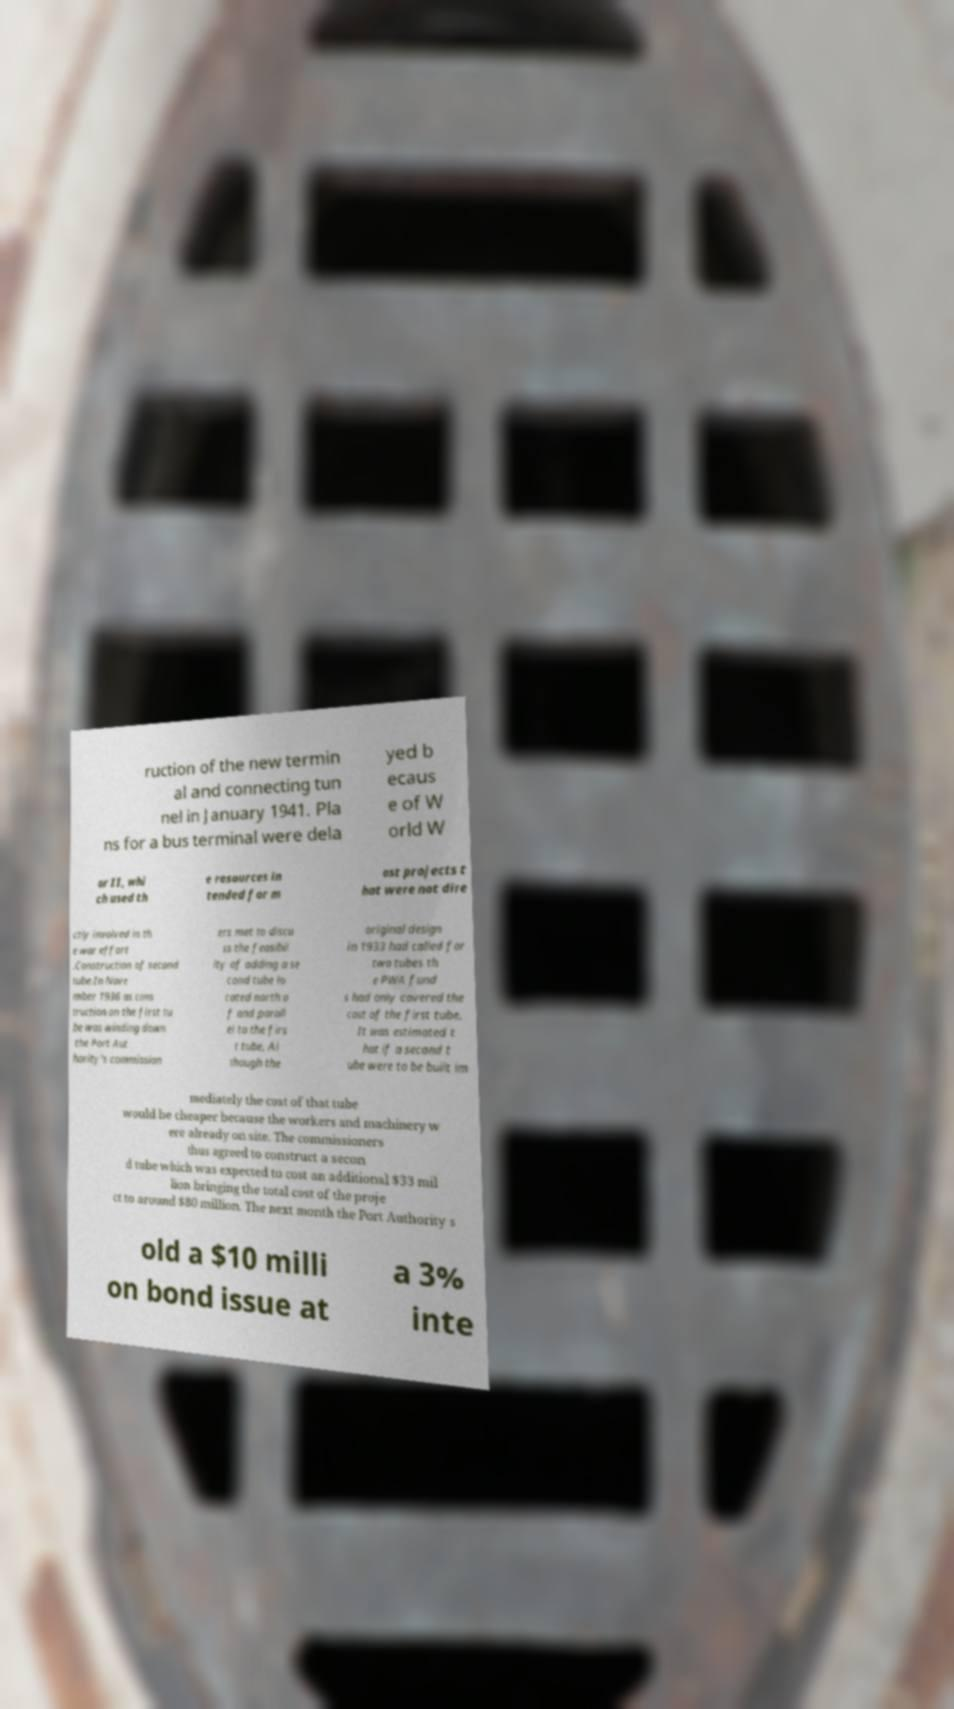What messages or text are displayed in this image? I need them in a readable, typed format. ruction of the new termin al and connecting tun nel in January 1941. Pla ns for a bus terminal were dela yed b ecaus e of W orld W ar II, whi ch used th e resources in tended for m ost projects t hat were not dire ctly involved in th e war effort .Construction of second tube.In Nove mber 1936 as cons truction on the first tu be was winding down the Port Aut hority's commission ers met to discu ss the feasibil ity of adding a se cond tube lo cated north o f and parall el to the firs t tube. Al though the original design in 1933 had called for two tubes th e PWA fund s had only covered the cost of the first tube. It was estimated t hat if a second t ube were to be built im mediately the cost of that tube would be cheaper because the workers and machinery w ere already on site. The commissioners thus agreed to construct a secon d tube which was expected to cost an additional $33 mil lion bringing the total cost of the proje ct to around $80 million. The next month the Port Authority s old a $10 milli on bond issue at a 3% inte 